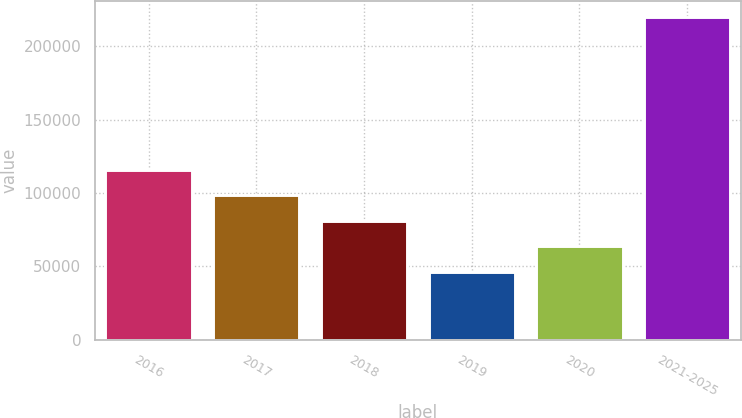Convert chart to OTSL. <chart><loc_0><loc_0><loc_500><loc_500><bar_chart><fcel>2016<fcel>2017<fcel>2018<fcel>2019<fcel>2020<fcel>2021-2025<nl><fcel>115962<fcel>98602<fcel>81242<fcel>46522<fcel>63882<fcel>220122<nl></chart> 